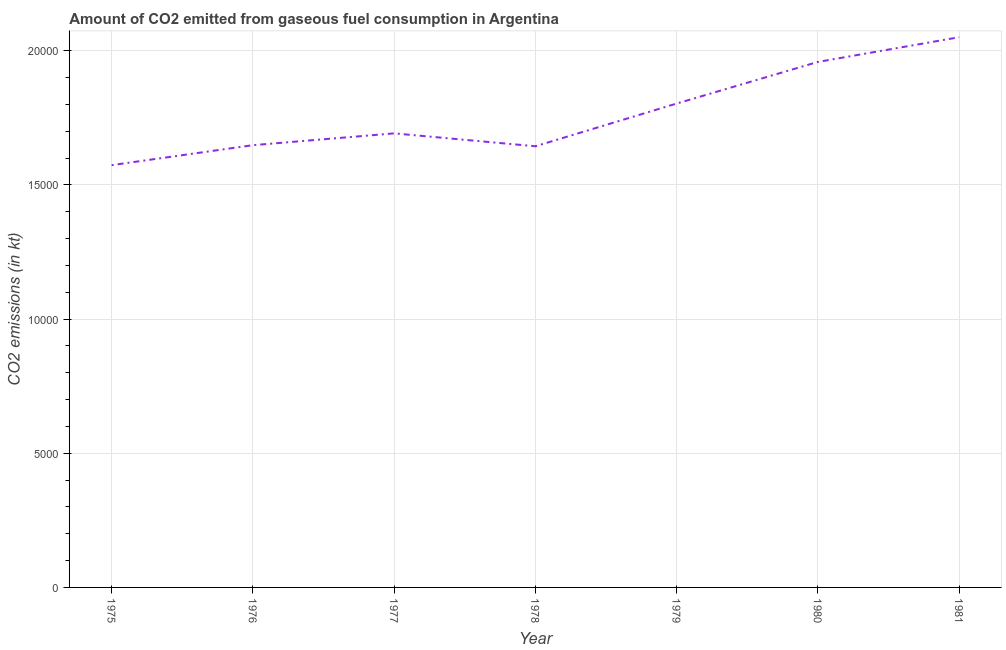What is the co2 emissions from gaseous fuel consumption in 1979?
Provide a succinct answer. 1.80e+04. Across all years, what is the maximum co2 emissions from gaseous fuel consumption?
Provide a succinct answer. 2.05e+04. Across all years, what is the minimum co2 emissions from gaseous fuel consumption?
Provide a succinct answer. 1.57e+04. In which year was the co2 emissions from gaseous fuel consumption maximum?
Your answer should be compact. 1981. In which year was the co2 emissions from gaseous fuel consumption minimum?
Your answer should be compact. 1975. What is the sum of the co2 emissions from gaseous fuel consumption?
Offer a terse response. 1.24e+05. What is the difference between the co2 emissions from gaseous fuel consumption in 1977 and 1979?
Keep it short and to the point. -1111.1. What is the average co2 emissions from gaseous fuel consumption per year?
Your response must be concise. 1.77e+04. What is the median co2 emissions from gaseous fuel consumption?
Give a very brief answer. 1.69e+04. What is the ratio of the co2 emissions from gaseous fuel consumption in 1978 to that in 1981?
Ensure brevity in your answer.  0.8. Is the difference between the co2 emissions from gaseous fuel consumption in 1978 and 1980 greater than the difference between any two years?
Offer a terse response. No. What is the difference between the highest and the second highest co2 emissions from gaseous fuel consumption?
Give a very brief answer. 920.42. What is the difference between the highest and the lowest co2 emissions from gaseous fuel consumption?
Give a very brief answer. 4767.1. In how many years, is the co2 emissions from gaseous fuel consumption greater than the average co2 emissions from gaseous fuel consumption taken over all years?
Ensure brevity in your answer.  3. Does the co2 emissions from gaseous fuel consumption monotonically increase over the years?
Provide a short and direct response. No. How many lines are there?
Offer a terse response. 1. How many years are there in the graph?
Keep it short and to the point. 7. What is the difference between two consecutive major ticks on the Y-axis?
Your response must be concise. 5000. Are the values on the major ticks of Y-axis written in scientific E-notation?
Keep it short and to the point. No. Does the graph contain any zero values?
Offer a terse response. No. What is the title of the graph?
Offer a very short reply. Amount of CO2 emitted from gaseous fuel consumption in Argentina. What is the label or title of the Y-axis?
Offer a very short reply. CO2 emissions (in kt). What is the CO2 emissions (in kt) of 1975?
Your response must be concise. 1.57e+04. What is the CO2 emissions (in kt) of 1976?
Provide a succinct answer. 1.65e+04. What is the CO2 emissions (in kt) of 1977?
Your answer should be compact. 1.69e+04. What is the CO2 emissions (in kt) in 1978?
Offer a very short reply. 1.64e+04. What is the CO2 emissions (in kt) of 1979?
Your answer should be compact. 1.80e+04. What is the CO2 emissions (in kt) in 1980?
Offer a terse response. 1.96e+04. What is the CO2 emissions (in kt) in 1981?
Keep it short and to the point. 2.05e+04. What is the difference between the CO2 emissions (in kt) in 1975 and 1976?
Make the answer very short. -744.4. What is the difference between the CO2 emissions (in kt) in 1975 and 1977?
Offer a very short reply. -1184.44. What is the difference between the CO2 emissions (in kt) in 1975 and 1978?
Your answer should be very brief. -704.06. What is the difference between the CO2 emissions (in kt) in 1975 and 1979?
Your answer should be compact. -2295.54. What is the difference between the CO2 emissions (in kt) in 1975 and 1980?
Provide a succinct answer. -3846.68. What is the difference between the CO2 emissions (in kt) in 1975 and 1981?
Your response must be concise. -4767.1. What is the difference between the CO2 emissions (in kt) in 1976 and 1977?
Make the answer very short. -440.04. What is the difference between the CO2 emissions (in kt) in 1976 and 1978?
Keep it short and to the point. 40.34. What is the difference between the CO2 emissions (in kt) in 1976 and 1979?
Make the answer very short. -1551.14. What is the difference between the CO2 emissions (in kt) in 1976 and 1980?
Provide a short and direct response. -3102.28. What is the difference between the CO2 emissions (in kt) in 1976 and 1981?
Ensure brevity in your answer.  -4022.7. What is the difference between the CO2 emissions (in kt) in 1977 and 1978?
Your response must be concise. 480.38. What is the difference between the CO2 emissions (in kt) in 1977 and 1979?
Make the answer very short. -1111.1. What is the difference between the CO2 emissions (in kt) in 1977 and 1980?
Give a very brief answer. -2662.24. What is the difference between the CO2 emissions (in kt) in 1977 and 1981?
Provide a short and direct response. -3582.66. What is the difference between the CO2 emissions (in kt) in 1978 and 1979?
Provide a succinct answer. -1591.48. What is the difference between the CO2 emissions (in kt) in 1978 and 1980?
Ensure brevity in your answer.  -3142.62. What is the difference between the CO2 emissions (in kt) in 1978 and 1981?
Give a very brief answer. -4063.04. What is the difference between the CO2 emissions (in kt) in 1979 and 1980?
Your response must be concise. -1551.14. What is the difference between the CO2 emissions (in kt) in 1979 and 1981?
Your response must be concise. -2471.56. What is the difference between the CO2 emissions (in kt) in 1980 and 1981?
Give a very brief answer. -920.42. What is the ratio of the CO2 emissions (in kt) in 1975 to that in 1976?
Your response must be concise. 0.95. What is the ratio of the CO2 emissions (in kt) in 1975 to that in 1978?
Offer a terse response. 0.96. What is the ratio of the CO2 emissions (in kt) in 1975 to that in 1979?
Provide a succinct answer. 0.87. What is the ratio of the CO2 emissions (in kt) in 1975 to that in 1980?
Make the answer very short. 0.8. What is the ratio of the CO2 emissions (in kt) in 1975 to that in 1981?
Offer a very short reply. 0.77. What is the ratio of the CO2 emissions (in kt) in 1976 to that in 1978?
Ensure brevity in your answer.  1. What is the ratio of the CO2 emissions (in kt) in 1976 to that in 1979?
Give a very brief answer. 0.91. What is the ratio of the CO2 emissions (in kt) in 1976 to that in 1980?
Provide a short and direct response. 0.84. What is the ratio of the CO2 emissions (in kt) in 1976 to that in 1981?
Your answer should be compact. 0.8. What is the ratio of the CO2 emissions (in kt) in 1977 to that in 1979?
Offer a terse response. 0.94. What is the ratio of the CO2 emissions (in kt) in 1977 to that in 1980?
Make the answer very short. 0.86. What is the ratio of the CO2 emissions (in kt) in 1977 to that in 1981?
Keep it short and to the point. 0.82. What is the ratio of the CO2 emissions (in kt) in 1978 to that in 1979?
Make the answer very short. 0.91. What is the ratio of the CO2 emissions (in kt) in 1978 to that in 1980?
Your answer should be very brief. 0.84. What is the ratio of the CO2 emissions (in kt) in 1978 to that in 1981?
Give a very brief answer. 0.8. What is the ratio of the CO2 emissions (in kt) in 1979 to that in 1980?
Your answer should be very brief. 0.92. What is the ratio of the CO2 emissions (in kt) in 1979 to that in 1981?
Your response must be concise. 0.88. What is the ratio of the CO2 emissions (in kt) in 1980 to that in 1981?
Your answer should be compact. 0.95. 